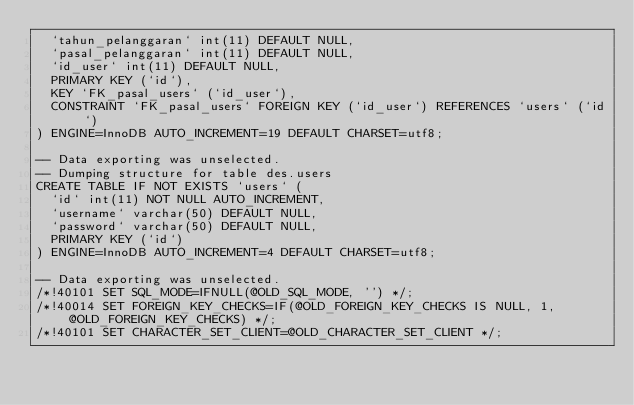Convert code to text. <code><loc_0><loc_0><loc_500><loc_500><_SQL_>  `tahun_pelanggaran` int(11) DEFAULT NULL,
  `pasal_pelanggaran` int(11) DEFAULT NULL,
  `id_user` int(11) DEFAULT NULL,
  PRIMARY KEY (`id`),
  KEY `FK_pasal_users` (`id_user`),
  CONSTRAINT `FK_pasal_users` FOREIGN KEY (`id_user`) REFERENCES `users` (`id`)
) ENGINE=InnoDB AUTO_INCREMENT=19 DEFAULT CHARSET=utf8;

-- Data exporting was unselected.
-- Dumping structure for table des.users
CREATE TABLE IF NOT EXISTS `users` (
  `id` int(11) NOT NULL AUTO_INCREMENT,
  `username` varchar(50) DEFAULT NULL,
  `password` varchar(50) DEFAULT NULL,
  PRIMARY KEY (`id`)
) ENGINE=InnoDB AUTO_INCREMENT=4 DEFAULT CHARSET=utf8;

-- Data exporting was unselected.
/*!40101 SET SQL_MODE=IFNULL(@OLD_SQL_MODE, '') */;
/*!40014 SET FOREIGN_KEY_CHECKS=IF(@OLD_FOREIGN_KEY_CHECKS IS NULL, 1, @OLD_FOREIGN_KEY_CHECKS) */;
/*!40101 SET CHARACTER_SET_CLIENT=@OLD_CHARACTER_SET_CLIENT */;
</code> 